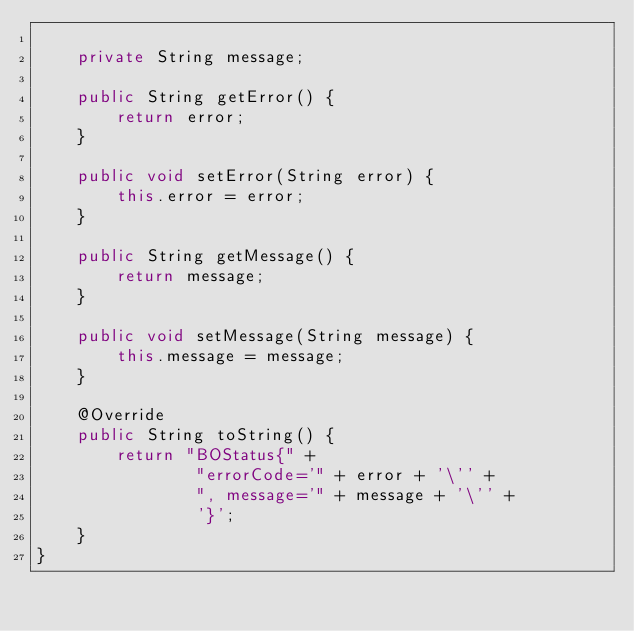<code> <loc_0><loc_0><loc_500><loc_500><_Java_>
    private String message;

    public String getError() {
        return error;
    }

    public void setError(String error) {
        this.error = error;
    }

    public String getMessage() {
        return message;
    }

    public void setMessage(String message) {
        this.message = message;
    }

    @Override
    public String toString() {
        return "BOStatus{" +
                "errorCode='" + error + '\'' +
                ", message='" + message + '\'' +
                '}';
    }
}
</code> 